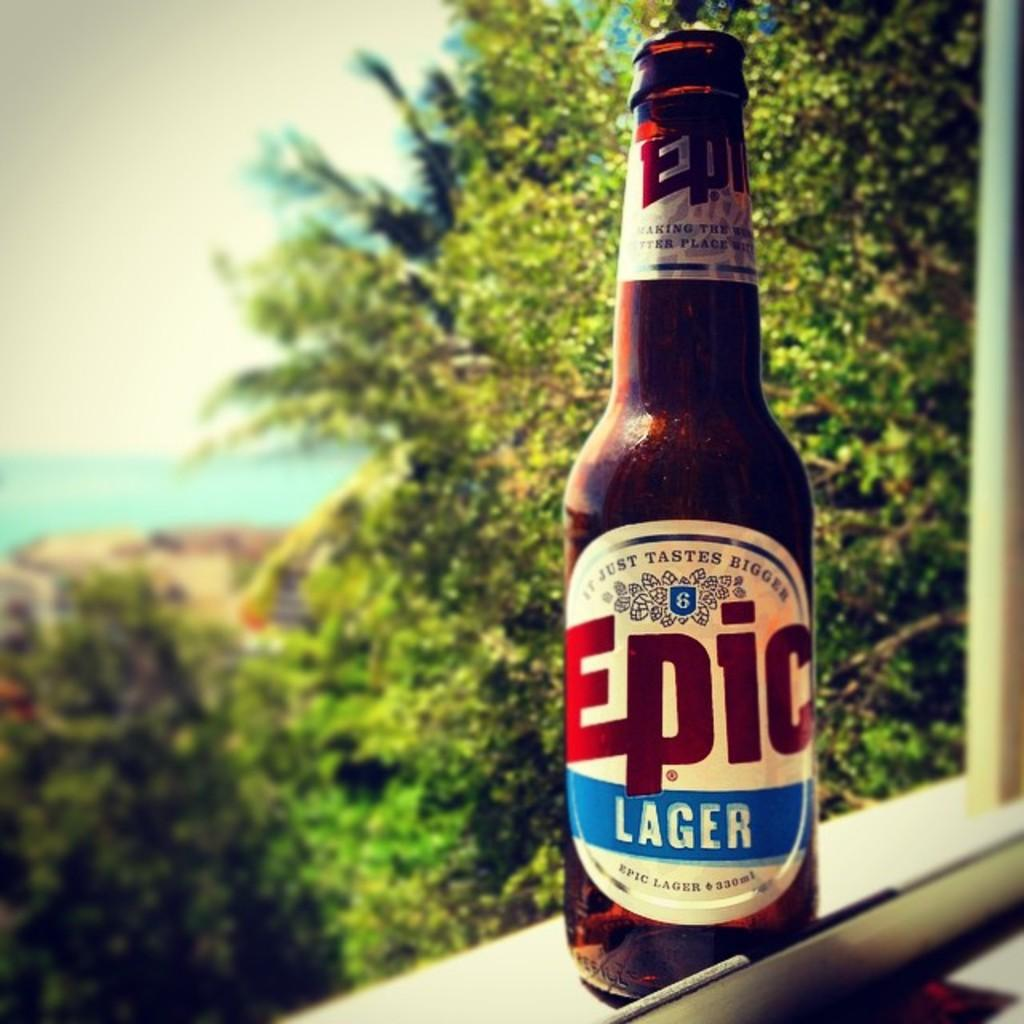<image>
Describe the image concisely. A bottle of Epic lager sits on a windowsill overlooking some trees. 